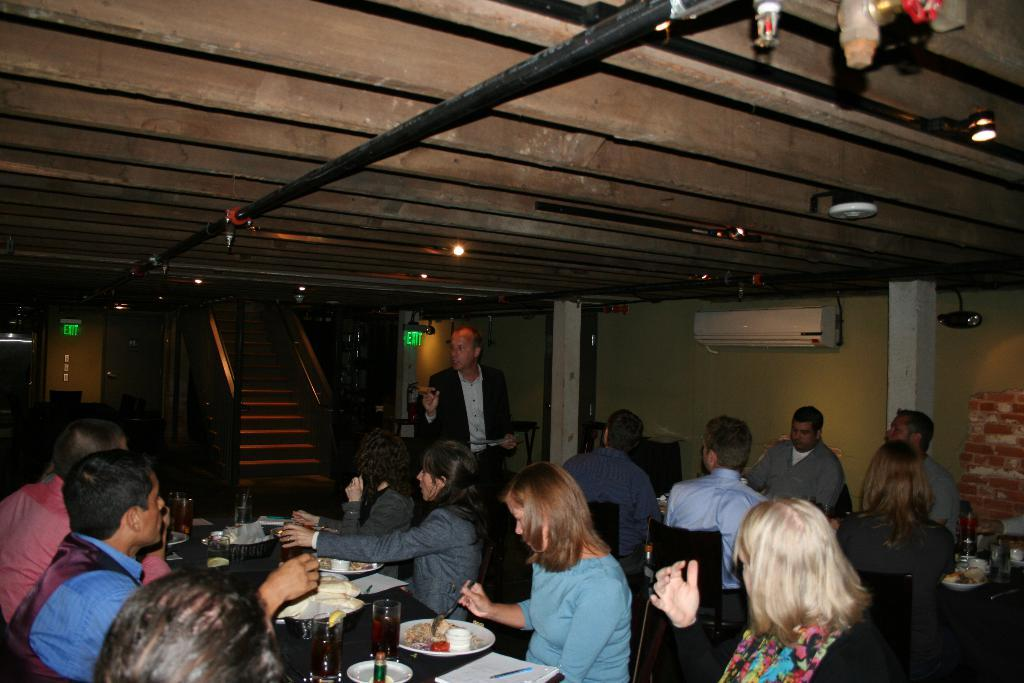What are the people in the image doing? The people in the image are sitting and dining. Where are the people located in relation to the table? The people are in front of a table. Can you describe the composition of the group? There are both men and women in the group. What can be seen in the background of the image? There are stairs in the background of the image, and one person is walking. What type of yard can be seen in the image? There is no yard visible in the image. What smell is associated with the food being eaten in the image? The image does not provide any information about the smell of the food being eaten. 